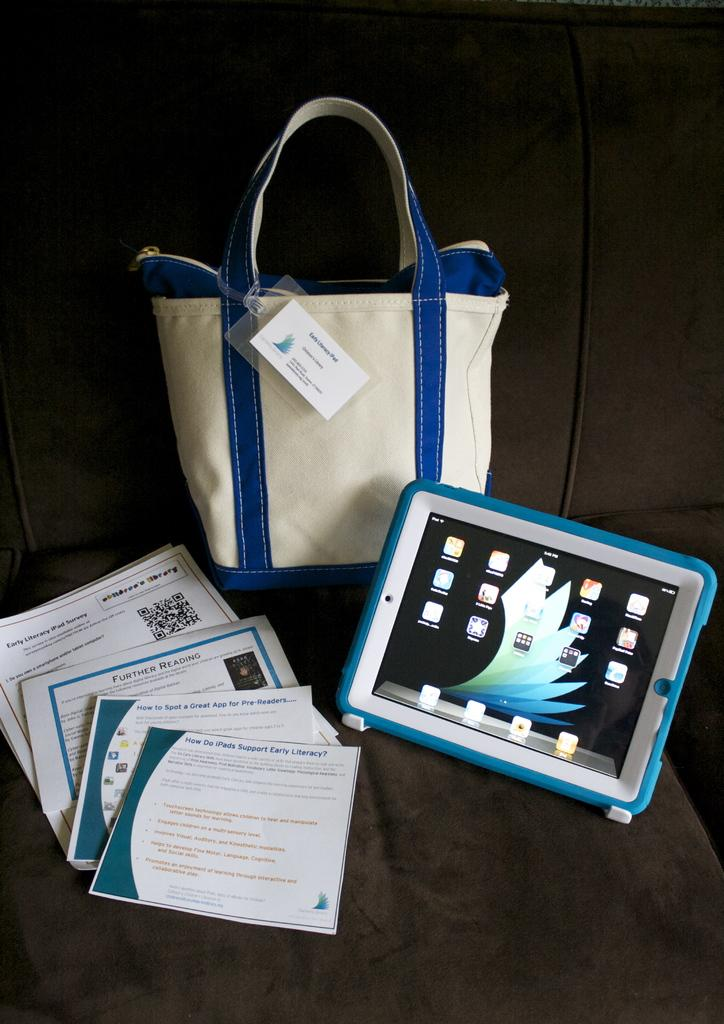What type of furniture is present in the image? There is a sofa in the image. What is placed on the sofa? There is a bag, an iPad, and some books placed on the sofa. What type of prose is being read from the books on the sofa? There is no indication of the type of prose being read from the books in the image. What shape is the school in the image? There is no school present in the image. 